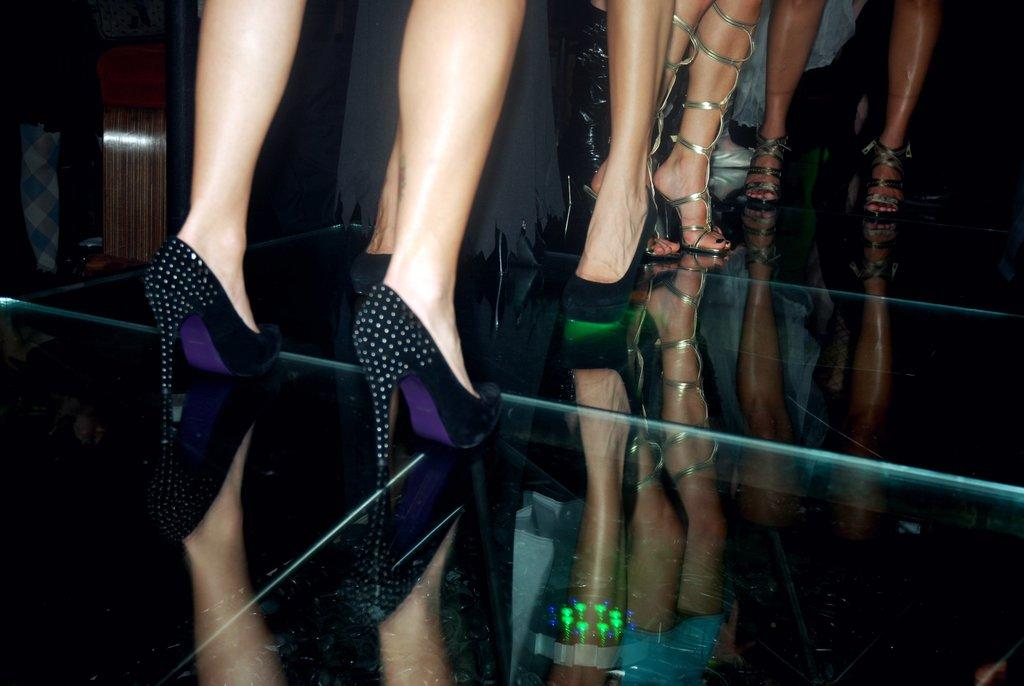What can be seen at the bottom of the image? There are legs with footwear visible in the image. What is the floor made of in the image? The floor appears to be made of glass. What type of object made of wood can be seen in the image? There is a wooden object in the image. What flavor of advertisement is being displayed on the wooden object in the image? There is no advertisement present in the image, and therefore no flavor can be associated with it. 